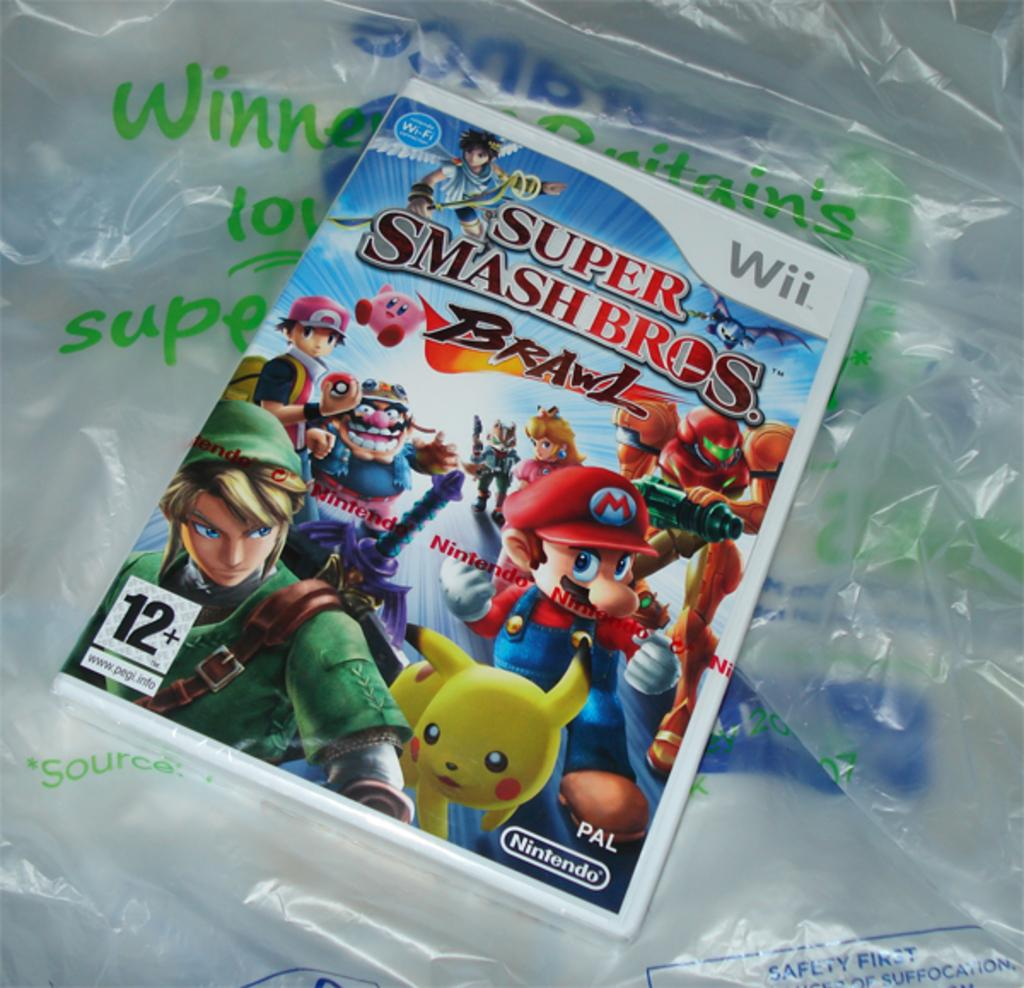What object is in the center of the image? There is a book in the center of the image. What is the book placed on? The book is on a cover. What type of linen is used to frame the book in the image? There is: There is no linen or framing present in the image; it simply shows a book on a cover. 